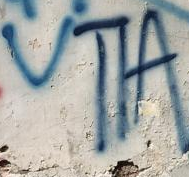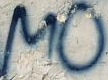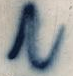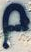Read the text content from these images in order, separated by a semicolon. VTIA; MO; N; p 